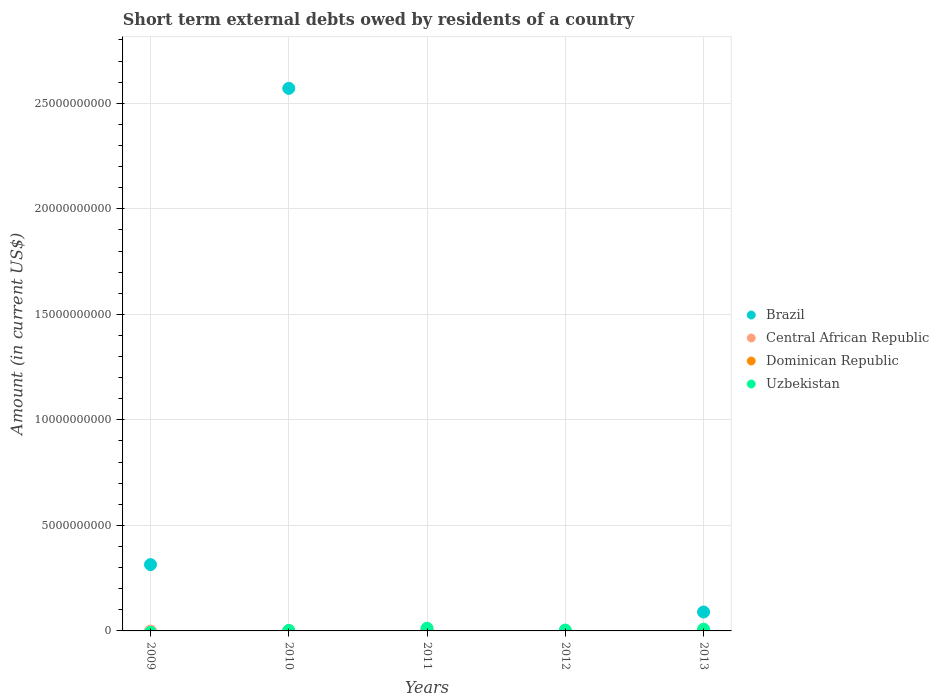How many different coloured dotlines are there?
Keep it short and to the point. 4. Is the number of dotlines equal to the number of legend labels?
Your answer should be compact. No. Across all years, what is the maximum amount of short-term external debts owed by residents in Brazil?
Make the answer very short. 2.57e+1. In which year was the amount of short-term external debts owed by residents in Uzbekistan maximum?
Offer a very short reply. 2011. What is the total amount of short-term external debts owed by residents in Uzbekistan in the graph?
Provide a succinct answer. 2.75e+08. What is the difference between the amount of short-term external debts owed by residents in Brazil in 2009 and that in 2013?
Your answer should be compact. 2.25e+09. What is the difference between the amount of short-term external debts owed by residents in Dominican Republic in 2011 and the amount of short-term external debts owed by residents in Central African Republic in 2012?
Keep it short and to the point. 4.57e+07. What is the average amount of short-term external debts owed by residents in Uzbekistan per year?
Your response must be concise. 5.50e+07. In the year 2011, what is the difference between the amount of short-term external debts owed by residents in Dominican Republic and amount of short-term external debts owed by residents in Uzbekistan?
Your answer should be very brief. -8.23e+07. What is the ratio of the amount of short-term external debts owed by residents in Uzbekistan in 2010 to that in 2013?
Your response must be concise. 0.29. Is the amount of short-term external debts owed by residents in Uzbekistan in 2011 less than that in 2013?
Keep it short and to the point. No. What is the difference between the highest and the second highest amount of short-term external debts owed by residents in Uzbekistan?
Your answer should be compact. 4.60e+07. What is the difference between the highest and the lowest amount of short-term external debts owed by residents in Dominican Republic?
Keep it short and to the point. 4.57e+07. In how many years, is the amount of short-term external debts owed by residents in Central African Republic greater than the average amount of short-term external debts owed by residents in Central African Republic taken over all years?
Give a very brief answer. 1. Is it the case that in every year, the sum of the amount of short-term external debts owed by residents in Dominican Republic and amount of short-term external debts owed by residents in Central African Republic  is greater than the sum of amount of short-term external debts owed by residents in Uzbekistan and amount of short-term external debts owed by residents in Brazil?
Give a very brief answer. No. Is the amount of short-term external debts owed by residents in Uzbekistan strictly less than the amount of short-term external debts owed by residents in Brazil over the years?
Provide a succinct answer. No. How many dotlines are there?
Give a very brief answer. 4. What is the difference between two consecutive major ticks on the Y-axis?
Give a very brief answer. 5.00e+09. Does the graph contain any zero values?
Offer a very short reply. Yes. Does the graph contain grids?
Offer a very short reply. Yes. How are the legend labels stacked?
Ensure brevity in your answer.  Vertical. What is the title of the graph?
Offer a terse response. Short term external debts owed by residents of a country. Does "Ghana" appear as one of the legend labels in the graph?
Ensure brevity in your answer.  No. What is the label or title of the X-axis?
Provide a succinct answer. Years. What is the label or title of the Y-axis?
Keep it short and to the point. Amount (in current US$). What is the Amount (in current US$) of Brazil in 2009?
Ensure brevity in your answer.  3.14e+09. What is the Amount (in current US$) in Uzbekistan in 2009?
Provide a short and direct response. 0. What is the Amount (in current US$) in Brazil in 2010?
Make the answer very short. 2.57e+1. What is the Amount (in current US$) of Uzbekistan in 2010?
Your response must be concise. 2.40e+07. What is the Amount (in current US$) in Brazil in 2011?
Keep it short and to the point. 0. What is the Amount (in current US$) in Central African Republic in 2011?
Your answer should be very brief. 3.10e+07. What is the Amount (in current US$) of Dominican Republic in 2011?
Offer a very short reply. 4.57e+07. What is the Amount (in current US$) in Uzbekistan in 2011?
Make the answer very short. 1.28e+08. What is the Amount (in current US$) of Brazil in 2012?
Give a very brief answer. 0. What is the Amount (in current US$) in Uzbekistan in 2012?
Your response must be concise. 4.10e+07. What is the Amount (in current US$) in Brazil in 2013?
Your answer should be compact. 8.97e+08. What is the Amount (in current US$) in Central African Republic in 2013?
Your answer should be very brief. 0. What is the Amount (in current US$) of Dominican Republic in 2013?
Your answer should be compact. 0. What is the Amount (in current US$) in Uzbekistan in 2013?
Provide a short and direct response. 8.20e+07. Across all years, what is the maximum Amount (in current US$) of Brazil?
Your answer should be compact. 2.57e+1. Across all years, what is the maximum Amount (in current US$) of Central African Republic?
Your response must be concise. 3.10e+07. Across all years, what is the maximum Amount (in current US$) in Dominican Republic?
Make the answer very short. 4.57e+07. Across all years, what is the maximum Amount (in current US$) in Uzbekistan?
Give a very brief answer. 1.28e+08. Across all years, what is the minimum Amount (in current US$) in Central African Republic?
Offer a terse response. 0. Across all years, what is the minimum Amount (in current US$) in Uzbekistan?
Your answer should be very brief. 0. What is the total Amount (in current US$) in Brazil in the graph?
Offer a terse response. 2.97e+1. What is the total Amount (in current US$) in Central African Republic in the graph?
Offer a very short reply. 3.10e+07. What is the total Amount (in current US$) of Dominican Republic in the graph?
Your answer should be very brief. 4.57e+07. What is the total Amount (in current US$) in Uzbekistan in the graph?
Your answer should be compact. 2.75e+08. What is the difference between the Amount (in current US$) in Brazil in 2009 and that in 2010?
Offer a very short reply. -2.26e+1. What is the difference between the Amount (in current US$) of Brazil in 2009 and that in 2013?
Ensure brevity in your answer.  2.25e+09. What is the difference between the Amount (in current US$) in Uzbekistan in 2010 and that in 2011?
Your answer should be compact. -1.04e+08. What is the difference between the Amount (in current US$) in Uzbekistan in 2010 and that in 2012?
Ensure brevity in your answer.  -1.70e+07. What is the difference between the Amount (in current US$) of Brazil in 2010 and that in 2013?
Provide a succinct answer. 2.48e+1. What is the difference between the Amount (in current US$) in Uzbekistan in 2010 and that in 2013?
Give a very brief answer. -5.80e+07. What is the difference between the Amount (in current US$) in Uzbekistan in 2011 and that in 2012?
Ensure brevity in your answer.  8.70e+07. What is the difference between the Amount (in current US$) in Uzbekistan in 2011 and that in 2013?
Your answer should be very brief. 4.60e+07. What is the difference between the Amount (in current US$) in Uzbekistan in 2012 and that in 2013?
Give a very brief answer. -4.10e+07. What is the difference between the Amount (in current US$) of Brazil in 2009 and the Amount (in current US$) of Uzbekistan in 2010?
Provide a short and direct response. 3.12e+09. What is the difference between the Amount (in current US$) in Brazil in 2009 and the Amount (in current US$) in Central African Republic in 2011?
Make the answer very short. 3.11e+09. What is the difference between the Amount (in current US$) of Brazil in 2009 and the Amount (in current US$) of Dominican Republic in 2011?
Keep it short and to the point. 3.10e+09. What is the difference between the Amount (in current US$) of Brazil in 2009 and the Amount (in current US$) of Uzbekistan in 2011?
Ensure brevity in your answer.  3.01e+09. What is the difference between the Amount (in current US$) in Brazil in 2009 and the Amount (in current US$) in Uzbekistan in 2012?
Offer a terse response. 3.10e+09. What is the difference between the Amount (in current US$) in Brazil in 2009 and the Amount (in current US$) in Uzbekistan in 2013?
Your answer should be compact. 3.06e+09. What is the difference between the Amount (in current US$) in Brazil in 2010 and the Amount (in current US$) in Central African Republic in 2011?
Your response must be concise. 2.57e+1. What is the difference between the Amount (in current US$) in Brazil in 2010 and the Amount (in current US$) in Dominican Republic in 2011?
Give a very brief answer. 2.57e+1. What is the difference between the Amount (in current US$) in Brazil in 2010 and the Amount (in current US$) in Uzbekistan in 2011?
Make the answer very short. 2.56e+1. What is the difference between the Amount (in current US$) of Brazil in 2010 and the Amount (in current US$) of Uzbekistan in 2012?
Offer a very short reply. 2.57e+1. What is the difference between the Amount (in current US$) in Brazil in 2010 and the Amount (in current US$) in Uzbekistan in 2013?
Keep it short and to the point. 2.56e+1. What is the difference between the Amount (in current US$) in Central African Republic in 2011 and the Amount (in current US$) in Uzbekistan in 2012?
Keep it short and to the point. -1.00e+07. What is the difference between the Amount (in current US$) of Dominican Republic in 2011 and the Amount (in current US$) of Uzbekistan in 2012?
Offer a terse response. 4.72e+06. What is the difference between the Amount (in current US$) in Central African Republic in 2011 and the Amount (in current US$) in Uzbekistan in 2013?
Provide a succinct answer. -5.10e+07. What is the difference between the Amount (in current US$) in Dominican Republic in 2011 and the Amount (in current US$) in Uzbekistan in 2013?
Your answer should be compact. -3.63e+07. What is the average Amount (in current US$) of Brazil per year?
Your answer should be very brief. 5.95e+09. What is the average Amount (in current US$) of Central African Republic per year?
Offer a terse response. 6.20e+06. What is the average Amount (in current US$) of Dominican Republic per year?
Ensure brevity in your answer.  9.14e+06. What is the average Amount (in current US$) in Uzbekistan per year?
Provide a succinct answer. 5.50e+07. In the year 2010, what is the difference between the Amount (in current US$) of Brazil and Amount (in current US$) of Uzbekistan?
Your answer should be compact. 2.57e+1. In the year 2011, what is the difference between the Amount (in current US$) of Central African Republic and Amount (in current US$) of Dominican Republic?
Offer a very short reply. -1.47e+07. In the year 2011, what is the difference between the Amount (in current US$) in Central African Republic and Amount (in current US$) in Uzbekistan?
Ensure brevity in your answer.  -9.70e+07. In the year 2011, what is the difference between the Amount (in current US$) in Dominican Republic and Amount (in current US$) in Uzbekistan?
Provide a short and direct response. -8.23e+07. In the year 2013, what is the difference between the Amount (in current US$) in Brazil and Amount (in current US$) in Uzbekistan?
Make the answer very short. 8.15e+08. What is the ratio of the Amount (in current US$) of Brazil in 2009 to that in 2010?
Offer a very short reply. 0.12. What is the ratio of the Amount (in current US$) in Brazil in 2009 to that in 2013?
Keep it short and to the point. 3.5. What is the ratio of the Amount (in current US$) of Uzbekistan in 2010 to that in 2011?
Ensure brevity in your answer.  0.19. What is the ratio of the Amount (in current US$) of Uzbekistan in 2010 to that in 2012?
Offer a very short reply. 0.59. What is the ratio of the Amount (in current US$) in Brazil in 2010 to that in 2013?
Offer a very short reply. 28.67. What is the ratio of the Amount (in current US$) in Uzbekistan in 2010 to that in 2013?
Your response must be concise. 0.29. What is the ratio of the Amount (in current US$) in Uzbekistan in 2011 to that in 2012?
Your answer should be very brief. 3.12. What is the ratio of the Amount (in current US$) of Uzbekistan in 2011 to that in 2013?
Provide a succinct answer. 1.56. What is the difference between the highest and the second highest Amount (in current US$) of Brazil?
Your response must be concise. 2.26e+1. What is the difference between the highest and the second highest Amount (in current US$) of Uzbekistan?
Provide a short and direct response. 4.60e+07. What is the difference between the highest and the lowest Amount (in current US$) in Brazil?
Offer a very short reply. 2.57e+1. What is the difference between the highest and the lowest Amount (in current US$) of Central African Republic?
Make the answer very short. 3.10e+07. What is the difference between the highest and the lowest Amount (in current US$) of Dominican Republic?
Ensure brevity in your answer.  4.57e+07. What is the difference between the highest and the lowest Amount (in current US$) of Uzbekistan?
Your response must be concise. 1.28e+08. 